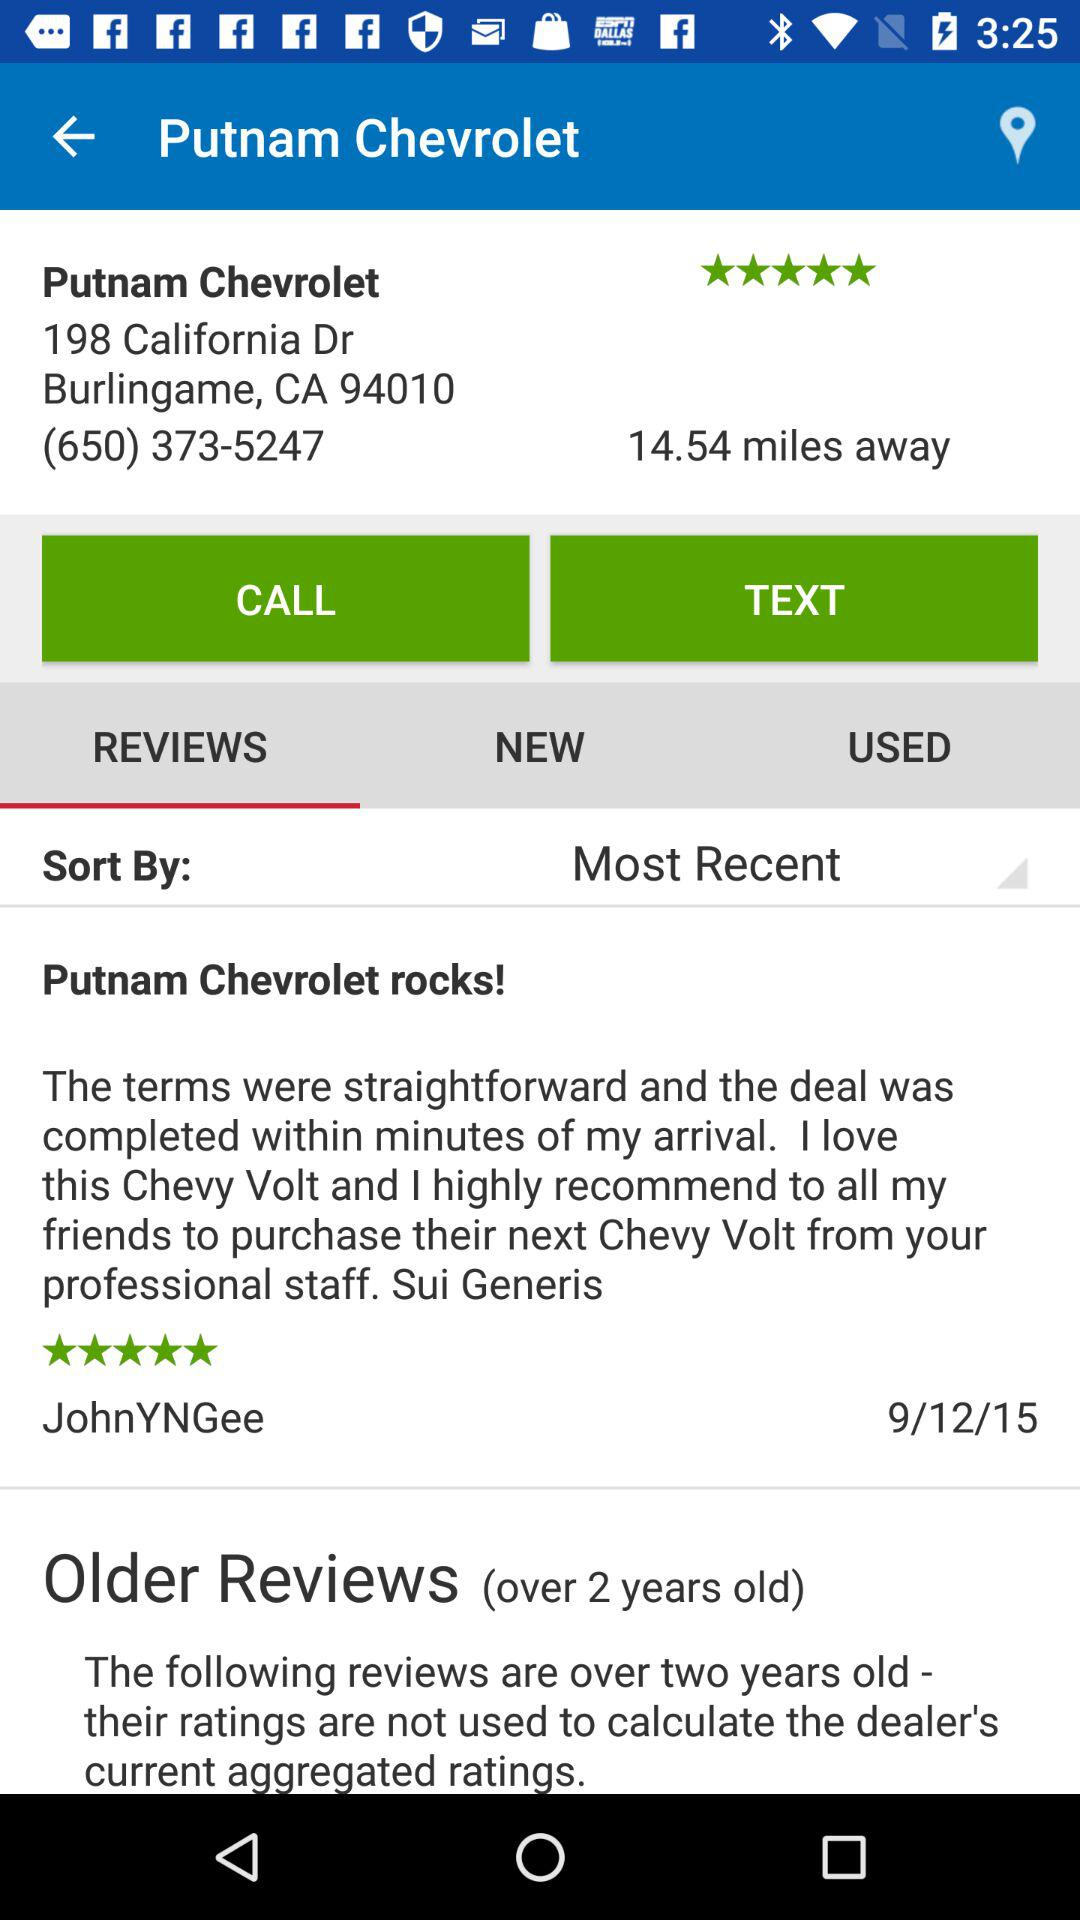What is the distance between Putnam Chevrolet and my location? The distance is 14.54 miles. 